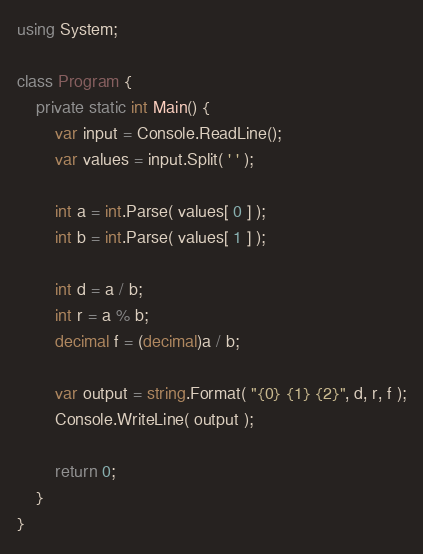Convert code to text. <code><loc_0><loc_0><loc_500><loc_500><_C#_>using System;

class Program {
    private static int Main() {
        var input = Console.ReadLine();
        var values = input.Split( ' ' );

        int a = int.Parse( values[ 0 ] );
        int b = int.Parse( values[ 1 ] );

        int d = a / b;
        int r = a % b;
        decimal f = (decimal)a / b;

        var output = string.Format( "{0} {1} {2}", d, r, f );
        Console.WriteLine( output );

        return 0;
    }
}</code> 